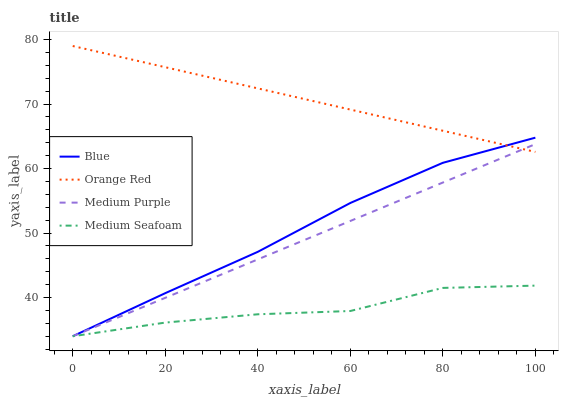Does Medium Purple have the minimum area under the curve?
Answer yes or no. No. Does Medium Purple have the maximum area under the curve?
Answer yes or no. No. Is Orange Red the smoothest?
Answer yes or no. No. Is Orange Red the roughest?
Answer yes or no. No. Does Orange Red have the lowest value?
Answer yes or no. No. Does Medium Purple have the highest value?
Answer yes or no. No. Is Medium Seafoam less than Orange Red?
Answer yes or no. Yes. Is Orange Red greater than Medium Seafoam?
Answer yes or no. Yes. Does Medium Seafoam intersect Orange Red?
Answer yes or no. No. 